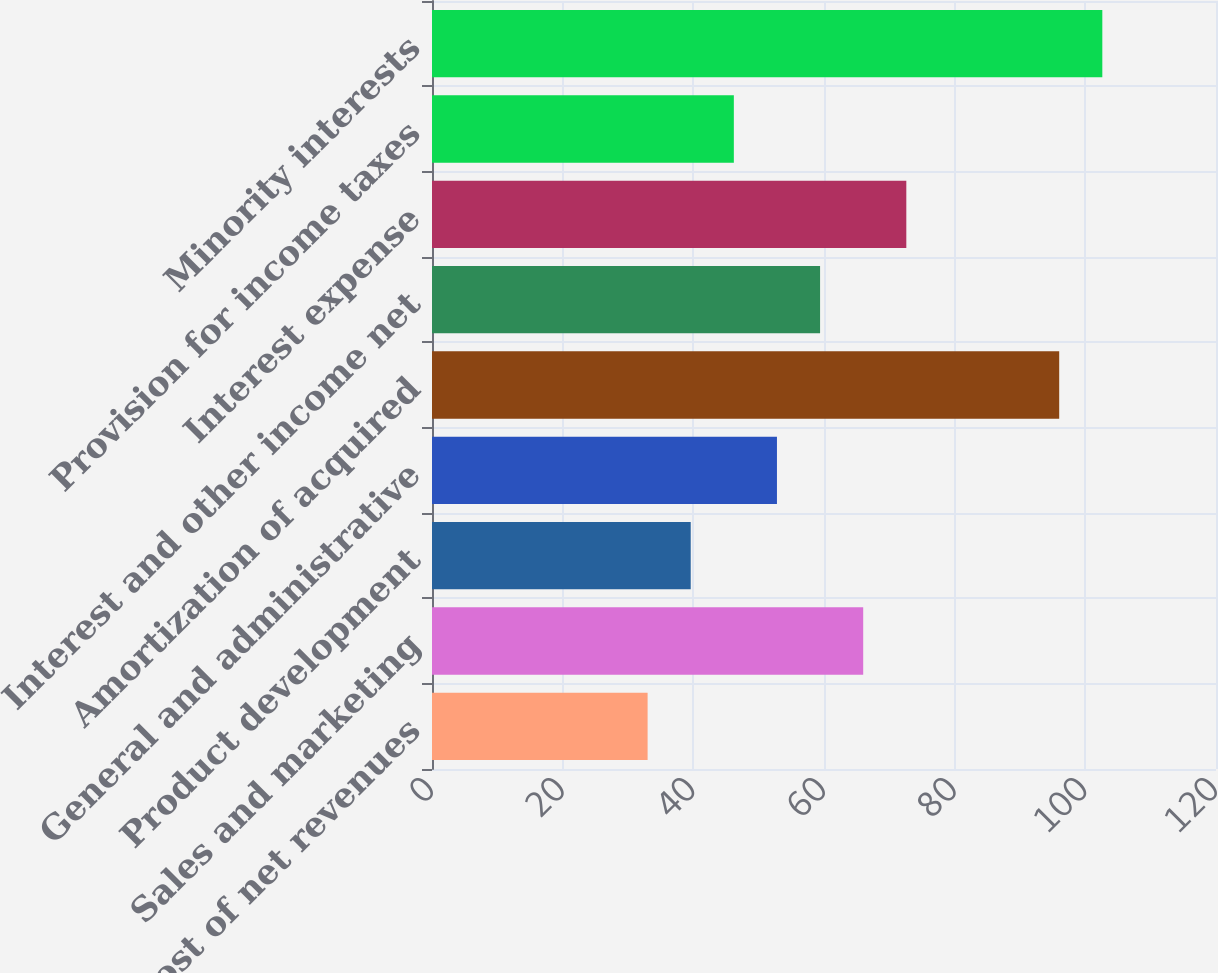Convert chart. <chart><loc_0><loc_0><loc_500><loc_500><bar_chart><fcel>Cost of net revenues<fcel>Sales and marketing<fcel>Product development<fcel>General and administrative<fcel>Amortization of acquired<fcel>Interest and other income net<fcel>Interest expense<fcel>Provision for income taxes<fcel>Minority interests<nl><fcel>33<fcel>66<fcel>39.6<fcel>52.8<fcel>96<fcel>59.4<fcel>72.6<fcel>46.2<fcel>102.6<nl></chart> 